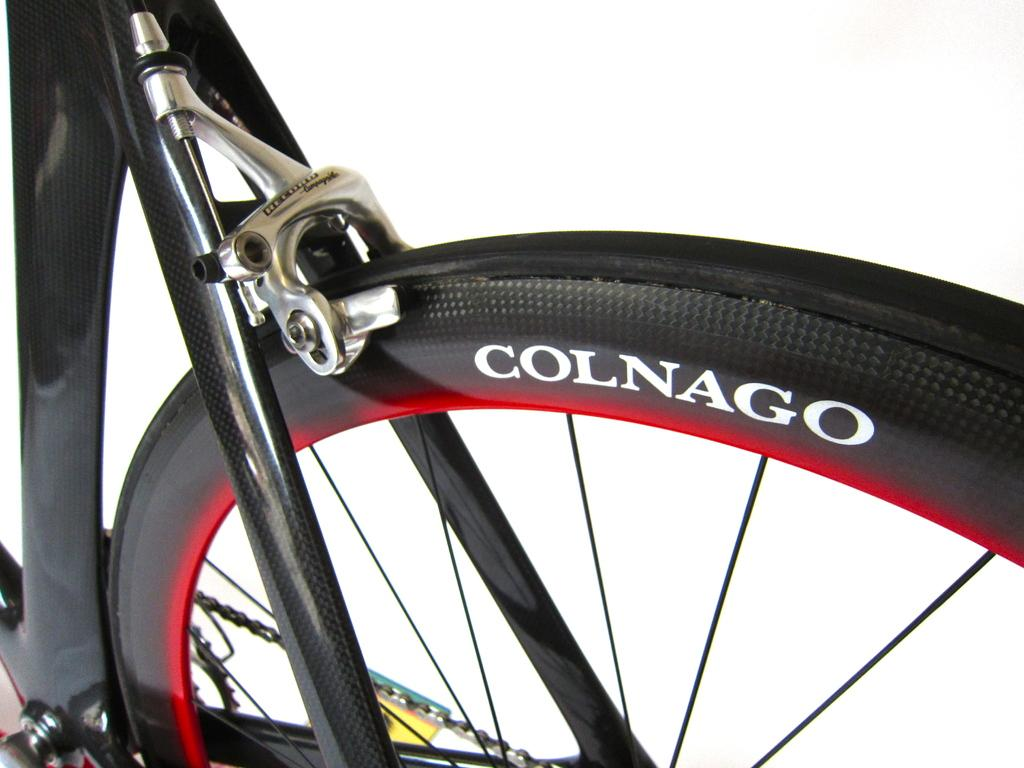What is the main subject of the image? The main subject of the image is a bicycle. Can you describe the image's perspective? The image is zoomed, providing a close-up view of the bicycle. How many nails can be seen holding the queen's portrait in the image? There are no nails or queen's portrait present in the image; it features a bicycle. 